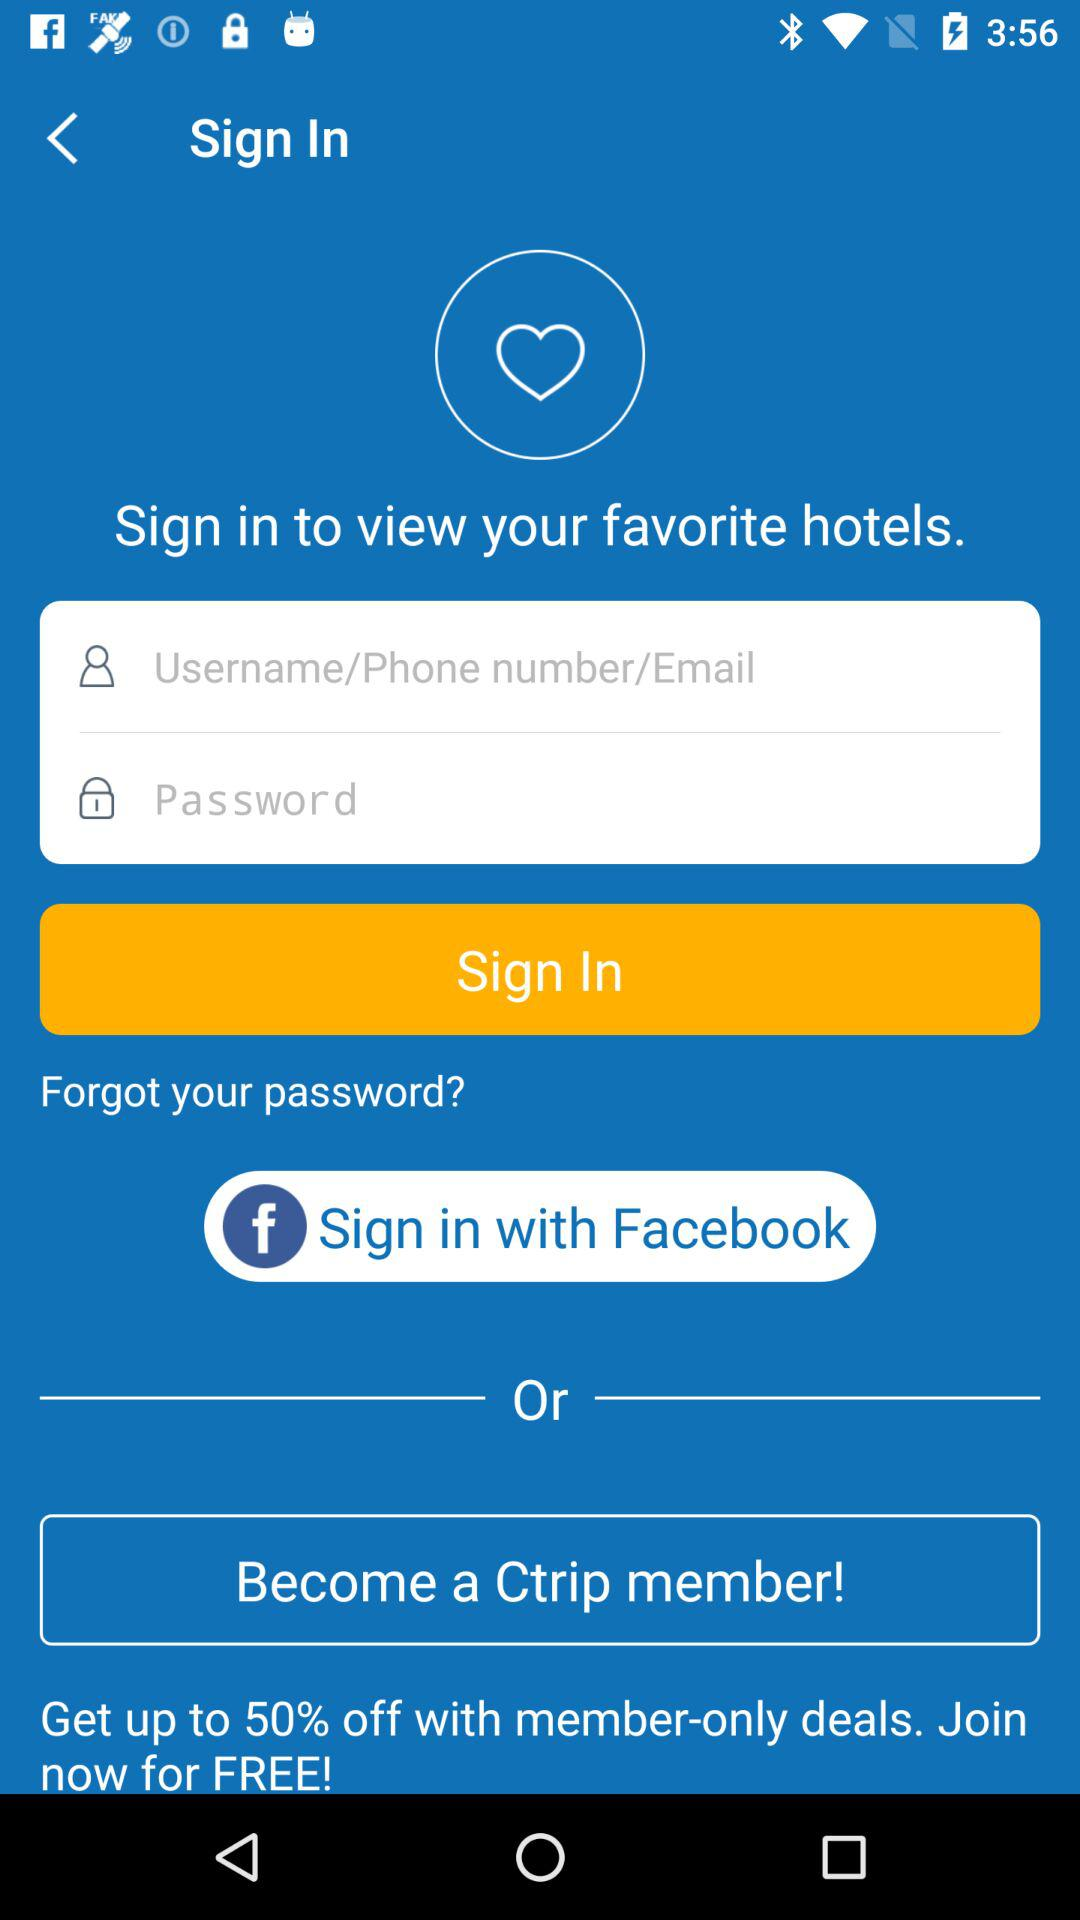What percentage is off with member-only deals? There is up to 50% off with member-only deals. 